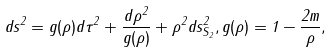<formula> <loc_0><loc_0><loc_500><loc_500>d s ^ { 2 } = g ( \rho ) d \tau ^ { 2 } + { \frac { d \rho ^ { 2 } } { g ( \rho ) } } + \rho ^ { 2 } d s _ { S _ { 2 } } ^ { 2 } , g ( \rho ) = 1 - { \frac { 2 m } { \rho } } ,</formula> 